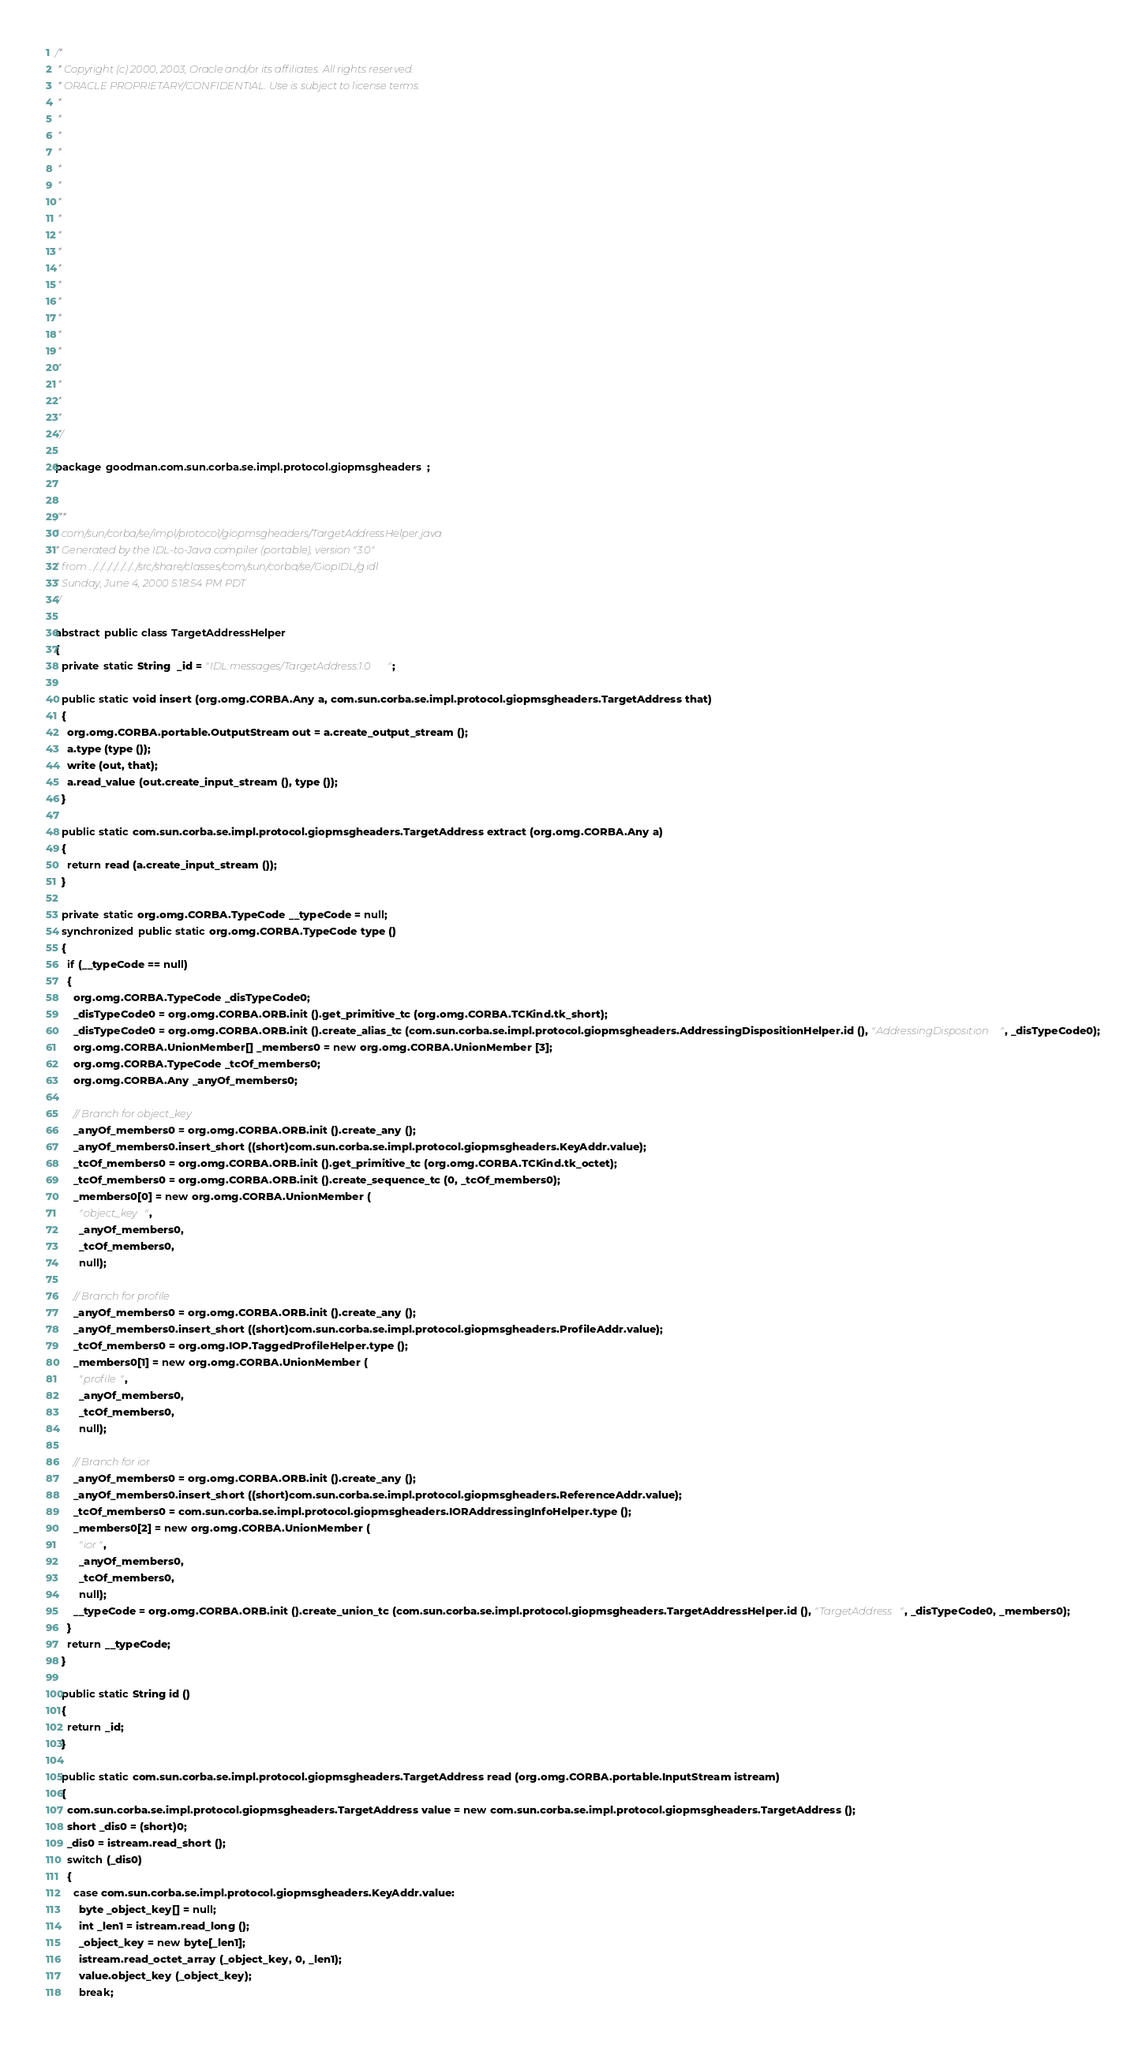Convert code to text. <code><loc_0><loc_0><loc_500><loc_500><_Java_>/*
 * Copyright (c) 2000, 2003, Oracle and/or its affiliates. All rights reserved.
 * ORACLE PROPRIETARY/CONFIDENTIAL. Use is subject to license terms.
 *
 *
 *
 *
 *
 *
 *
 *
 *
 *
 *
 *
 *
 *
 *
 *
 *
 *
 *
 *
 */

package goodman.com.sun.corba.se.impl.protocol.giopmsgheaders;


/**
* com/sun/corba/se/impl/protocol/giopmsgheaders/TargetAddressHelper.java
* Generated by the IDL-to-Java compiler (portable), version "3.0"
* from ../../../../../../../src/share/classes/com/sun/corba/se/GiopIDL/g.idl
* Sunday, June 4, 2000 5:18:54 PM PDT
*/

abstract public class TargetAddressHelper
{
  private static String  _id = "IDL:messages/TargetAddress:1.0";

  public static void insert (org.omg.CORBA.Any a, com.sun.corba.se.impl.protocol.giopmsgheaders.TargetAddress that)
  {
    org.omg.CORBA.portable.OutputStream out = a.create_output_stream ();
    a.type (type ());
    write (out, that);
    a.read_value (out.create_input_stream (), type ());
  }

  public static com.sun.corba.se.impl.protocol.giopmsgheaders.TargetAddress extract (org.omg.CORBA.Any a)
  {
    return read (a.create_input_stream ());
  }

  private static org.omg.CORBA.TypeCode __typeCode = null;
  synchronized public static org.omg.CORBA.TypeCode type ()
  {
    if (__typeCode == null)
    {
      org.omg.CORBA.TypeCode _disTypeCode0;
      _disTypeCode0 = org.omg.CORBA.ORB.init ().get_primitive_tc (org.omg.CORBA.TCKind.tk_short);
      _disTypeCode0 = org.omg.CORBA.ORB.init ().create_alias_tc (com.sun.corba.se.impl.protocol.giopmsgheaders.AddressingDispositionHelper.id (), "AddressingDisposition", _disTypeCode0);
      org.omg.CORBA.UnionMember[] _members0 = new org.omg.CORBA.UnionMember [3];
      org.omg.CORBA.TypeCode _tcOf_members0;
      org.omg.CORBA.Any _anyOf_members0;

      // Branch for object_key
      _anyOf_members0 = org.omg.CORBA.ORB.init ().create_any ();
      _anyOf_members0.insert_short ((short)com.sun.corba.se.impl.protocol.giopmsgheaders.KeyAddr.value);
      _tcOf_members0 = org.omg.CORBA.ORB.init ().get_primitive_tc (org.omg.CORBA.TCKind.tk_octet);
      _tcOf_members0 = org.omg.CORBA.ORB.init ().create_sequence_tc (0, _tcOf_members0);
      _members0[0] = new org.omg.CORBA.UnionMember (
        "object_key",
        _anyOf_members0,
        _tcOf_members0,
        null);

      // Branch for profile
      _anyOf_members0 = org.omg.CORBA.ORB.init ().create_any ();
      _anyOf_members0.insert_short ((short)com.sun.corba.se.impl.protocol.giopmsgheaders.ProfileAddr.value);
      _tcOf_members0 = org.omg.IOP.TaggedProfileHelper.type ();
      _members0[1] = new org.omg.CORBA.UnionMember (
        "profile",
        _anyOf_members0,
        _tcOf_members0,
        null);

      // Branch for ior
      _anyOf_members0 = org.omg.CORBA.ORB.init ().create_any ();
      _anyOf_members0.insert_short ((short)com.sun.corba.se.impl.protocol.giopmsgheaders.ReferenceAddr.value);
      _tcOf_members0 = com.sun.corba.se.impl.protocol.giopmsgheaders.IORAddressingInfoHelper.type ();
      _members0[2] = new org.omg.CORBA.UnionMember (
        "ior",
        _anyOf_members0,
        _tcOf_members0,
        null);
      __typeCode = org.omg.CORBA.ORB.init ().create_union_tc (com.sun.corba.se.impl.protocol.giopmsgheaders.TargetAddressHelper.id (), "TargetAddress", _disTypeCode0, _members0);
    }
    return __typeCode;
  }

  public static String id ()
  {
    return _id;
  }

  public static com.sun.corba.se.impl.protocol.giopmsgheaders.TargetAddress read (org.omg.CORBA.portable.InputStream istream)
  {
    com.sun.corba.se.impl.protocol.giopmsgheaders.TargetAddress value = new com.sun.corba.se.impl.protocol.giopmsgheaders.TargetAddress ();
    short _dis0 = (short)0;
    _dis0 = istream.read_short ();
    switch (_dis0)
    {
      case com.sun.corba.se.impl.protocol.giopmsgheaders.KeyAddr.value:
        byte _object_key[] = null;
        int _len1 = istream.read_long ();
        _object_key = new byte[_len1];
        istream.read_octet_array (_object_key, 0, _len1);
        value.object_key (_object_key);
        break;</code> 